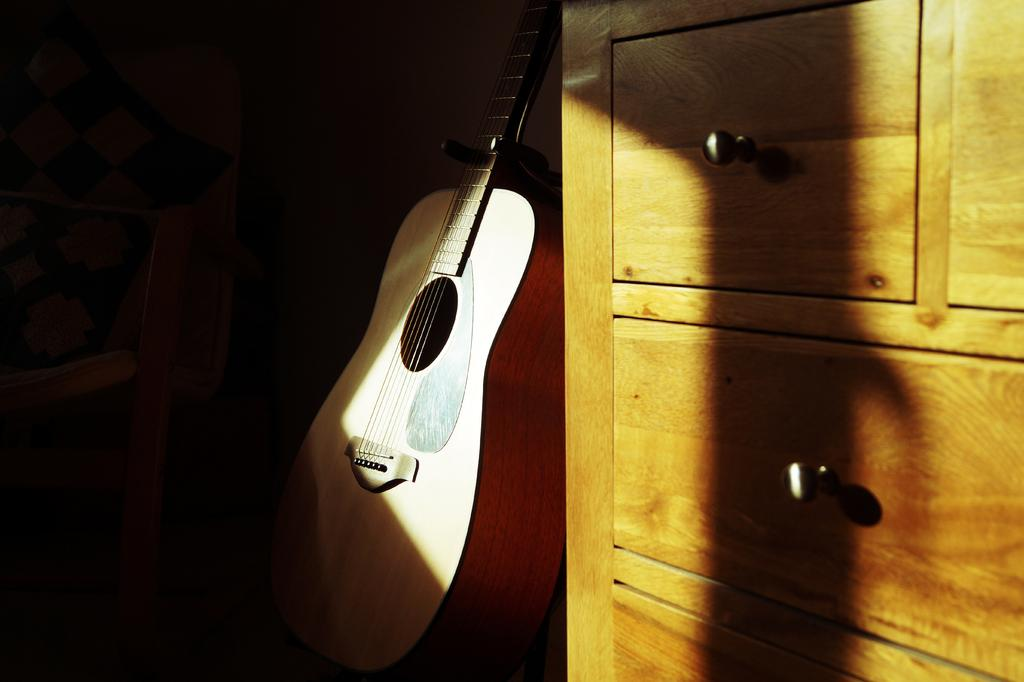What is the main object in the middle of the image? There is a guitar in the middle of the image. What type of furniture can be seen on the right side of the image? There is a cupboard on the right side of the image. What type of seating is on the left side of the image? There is a chair on the left side of the image. What type of creature is sitting on the guitar in the image? There is no creature present in the image, and the guitar is not being sat on. How many cows can be seen in the image? There are no cows present in the image. 